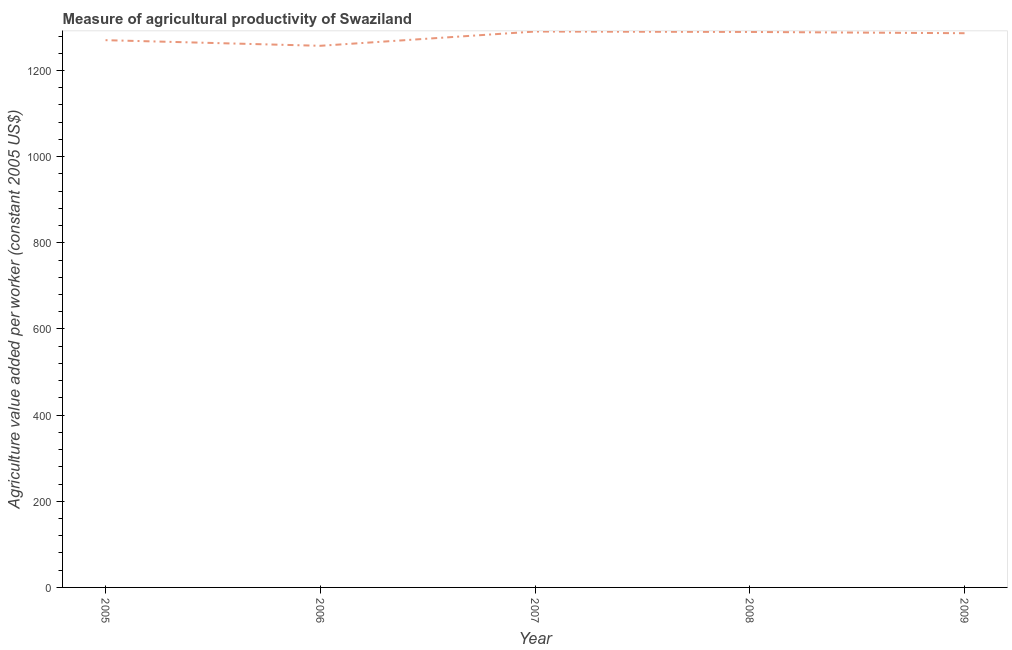What is the agriculture value added per worker in 2006?
Make the answer very short. 1257.32. Across all years, what is the maximum agriculture value added per worker?
Offer a terse response. 1290.42. Across all years, what is the minimum agriculture value added per worker?
Give a very brief answer. 1257.32. What is the sum of the agriculture value added per worker?
Make the answer very short. 6394.13. What is the difference between the agriculture value added per worker in 2006 and 2009?
Keep it short and to the point. -29.21. What is the average agriculture value added per worker per year?
Your response must be concise. 1278.83. What is the median agriculture value added per worker?
Your answer should be very brief. 1286.53. Do a majority of the years between 2005 and 2008 (inclusive) have agriculture value added per worker greater than 1200 US$?
Provide a short and direct response. Yes. What is the ratio of the agriculture value added per worker in 2008 to that in 2009?
Keep it short and to the point. 1. Is the difference between the agriculture value added per worker in 2005 and 2009 greater than the difference between any two years?
Ensure brevity in your answer.  No. What is the difference between the highest and the second highest agriculture value added per worker?
Offer a terse response. 0.94. Is the sum of the agriculture value added per worker in 2005 and 2008 greater than the maximum agriculture value added per worker across all years?
Offer a very short reply. Yes. What is the difference between the highest and the lowest agriculture value added per worker?
Ensure brevity in your answer.  33.09. Are the values on the major ticks of Y-axis written in scientific E-notation?
Ensure brevity in your answer.  No. Does the graph contain any zero values?
Your answer should be compact. No. What is the title of the graph?
Ensure brevity in your answer.  Measure of agricultural productivity of Swaziland. What is the label or title of the X-axis?
Ensure brevity in your answer.  Year. What is the label or title of the Y-axis?
Give a very brief answer. Agriculture value added per worker (constant 2005 US$). What is the Agriculture value added per worker (constant 2005 US$) of 2005?
Provide a succinct answer. 1270.38. What is the Agriculture value added per worker (constant 2005 US$) of 2006?
Your answer should be compact. 1257.32. What is the Agriculture value added per worker (constant 2005 US$) of 2007?
Ensure brevity in your answer.  1290.42. What is the Agriculture value added per worker (constant 2005 US$) in 2008?
Provide a succinct answer. 1289.48. What is the Agriculture value added per worker (constant 2005 US$) in 2009?
Give a very brief answer. 1286.53. What is the difference between the Agriculture value added per worker (constant 2005 US$) in 2005 and 2006?
Your answer should be very brief. 13.05. What is the difference between the Agriculture value added per worker (constant 2005 US$) in 2005 and 2007?
Your response must be concise. -20.04. What is the difference between the Agriculture value added per worker (constant 2005 US$) in 2005 and 2008?
Keep it short and to the point. -19.1. What is the difference between the Agriculture value added per worker (constant 2005 US$) in 2005 and 2009?
Your answer should be very brief. -16.15. What is the difference between the Agriculture value added per worker (constant 2005 US$) in 2006 and 2007?
Make the answer very short. -33.09. What is the difference between the Agriculture value added per worker (constant 2005 US$) in 2006 and 2008?
Offer a terse response. -32.15. What is the difference between the Agriculture value added per worker (constant 2005 US$) in 2006 and 2009?
Offer a very short reply. -29.21. What is the difference between the Agriculture value added per worker (constant 2005 US$) in 2007 and 2008?
Provide a short and direct response. 0.94. What is the difference between the Agriculture value added per worker (constant 2005 US$) in 2007 and 2009?
Ensure brevity in your answer.  3.89. What is the difference between the Agriculture value added per worker (constant 2005 US$) in 2008 and 2009?
Provide a short and direct response. 2.95. What is the ratio of the Agriculture value added per worker (constant 2005 US$) in 2005 to that in 2006?
Provide a succinct answer. 1.01. What is the ratio of the Agriculture value added per worker (constant 2005 US$) in 2005 to that in 2008?
Ensure brevity in your answer.  0.98. What is the ratio of the Agriculture value added per worker (constant 2005 US$) in 2005 to that in 2009?
Provide a short and direct response. 0.99. What is the ratio of the Agriculture value added per worker (constant 2005 US$) in 2006 to that in 2007?
Keep it short and to the point. 0.97. What is the ratio of the Agriculture value added per worker (constant 2005 US$) in 2006 to that in 2009?
Make the answer very short. 0.98. What is the ratio of the Agriculture value added per worker (constant 2005 US$) in 2007 to that in 2009?
Offer a terse response. 1. 